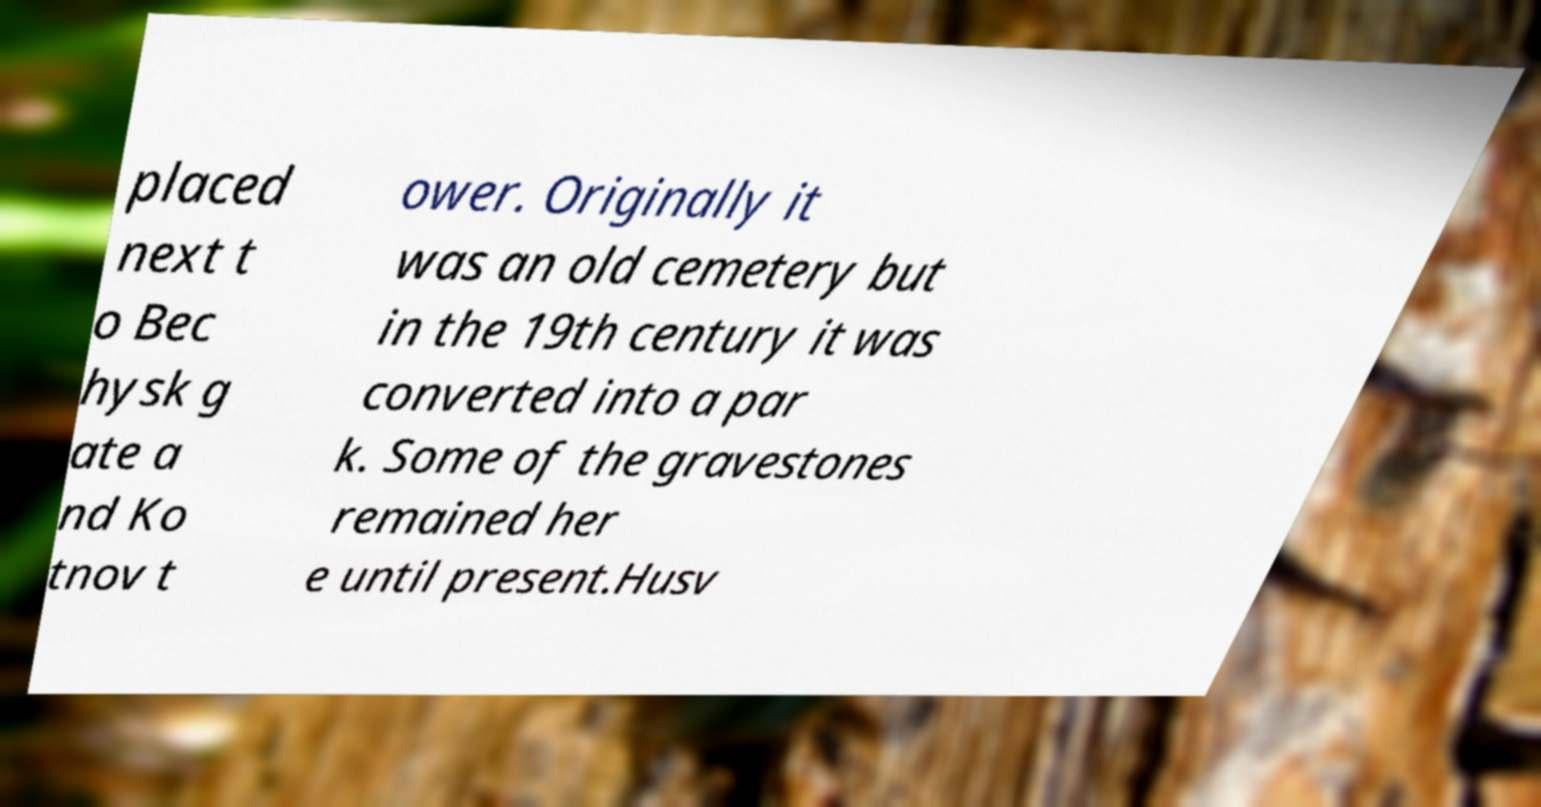What messages or text are displayed in this image? I need them in a readable, typed format. placed next t o Bec hysk g ate a nd Ko tnov t ower. Originally it was an old cemetery but in the 19th century it was converted into a par k. Some of the gravestones remained her e until present.Husv 